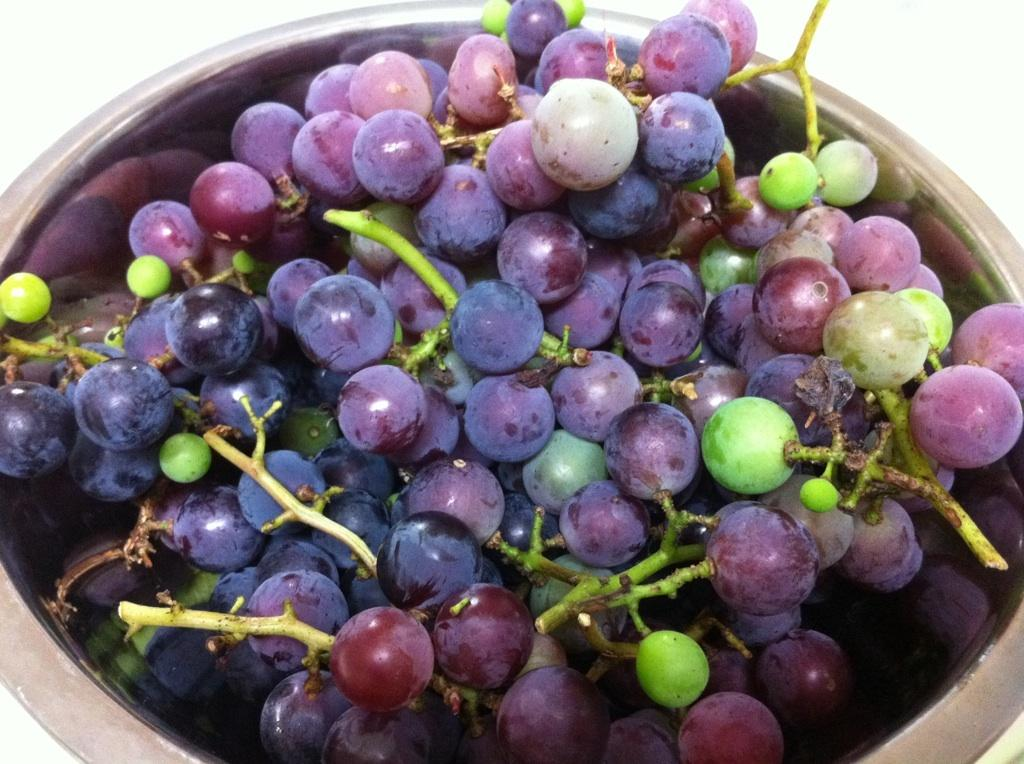What type of fruit is present in the image? There are grapes in the image. Where are the grapes located? The grapes are in a bowl. How many holes are visible in the grapes in the image? There are no holes visible in the grapes in the image. Grapes do not have holes; they are individual berries that grow on a vine. 